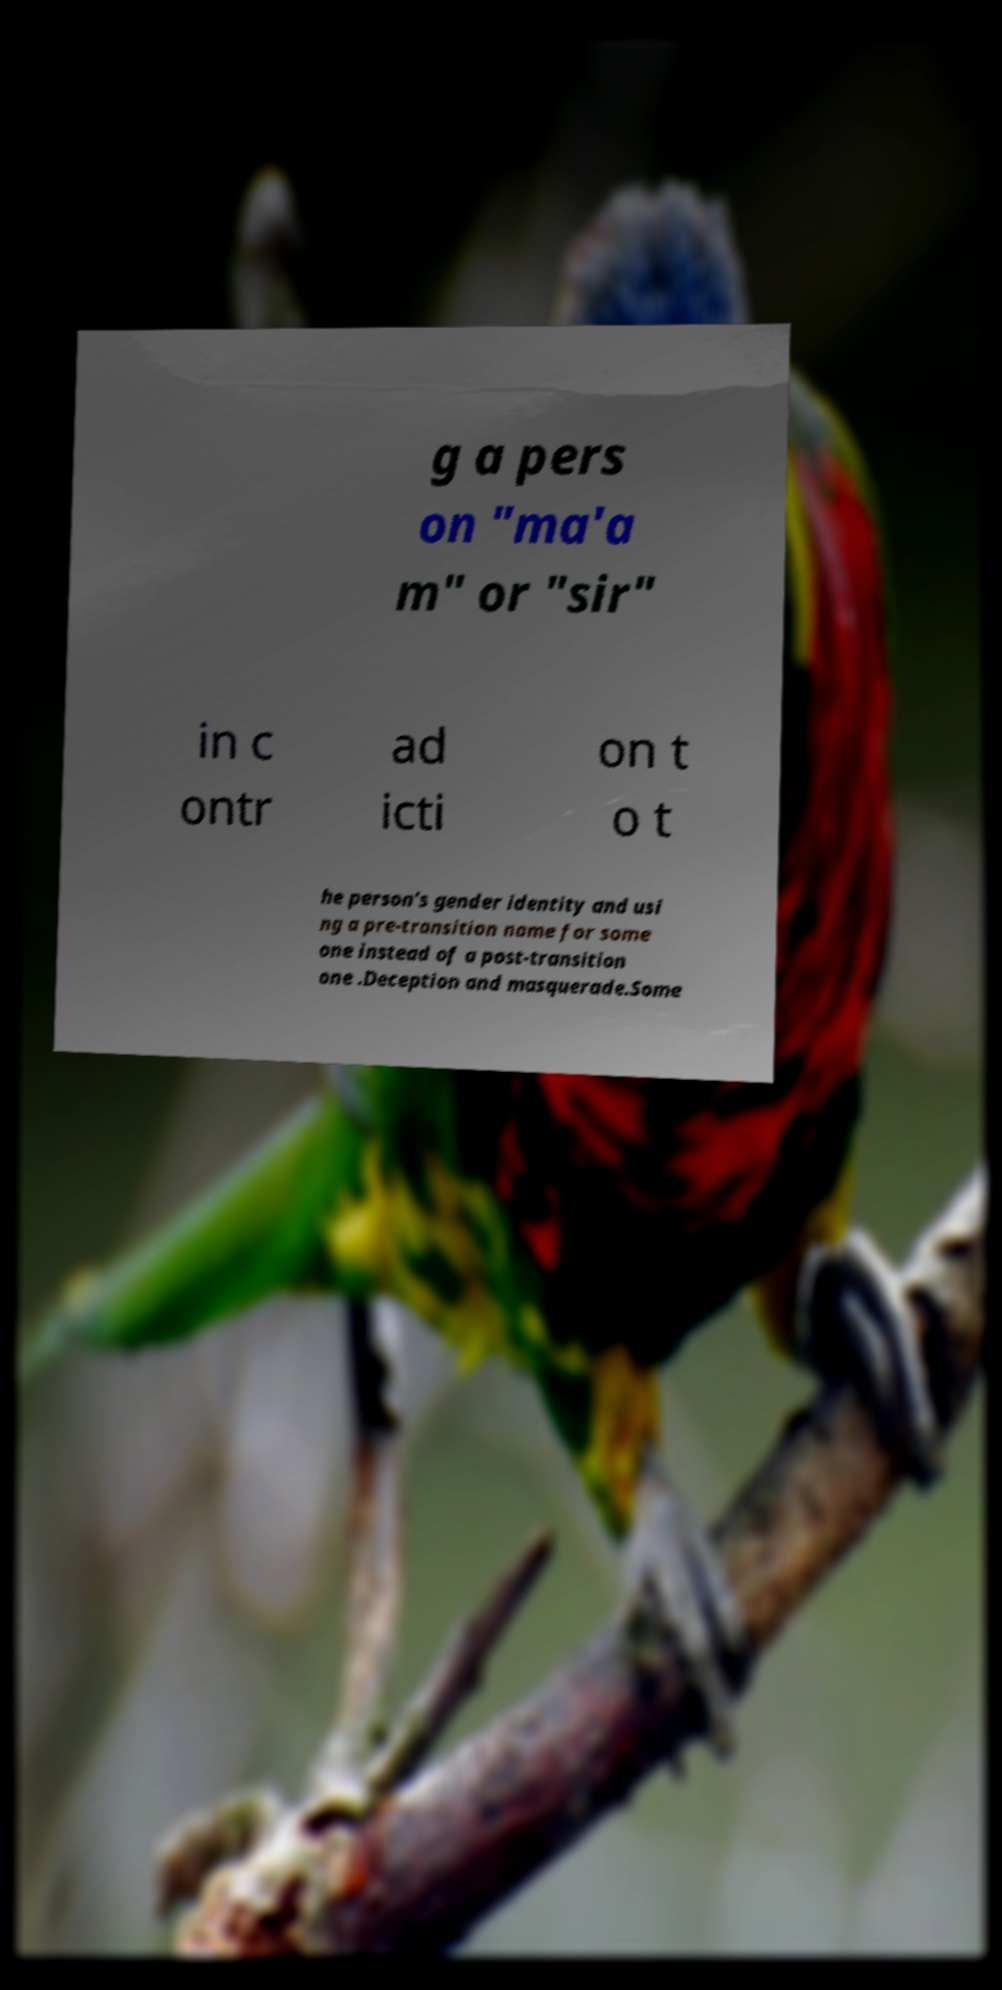For documentation purposes, I need the text within this image transcribed. Could you provide that? g a pers on "ma'a m" or "sir" in c ontr ad icti on t o t he person's gender identity and usi ng a pre-transition name for some one instead of a post-transition one .Deception and masquerade.Some 